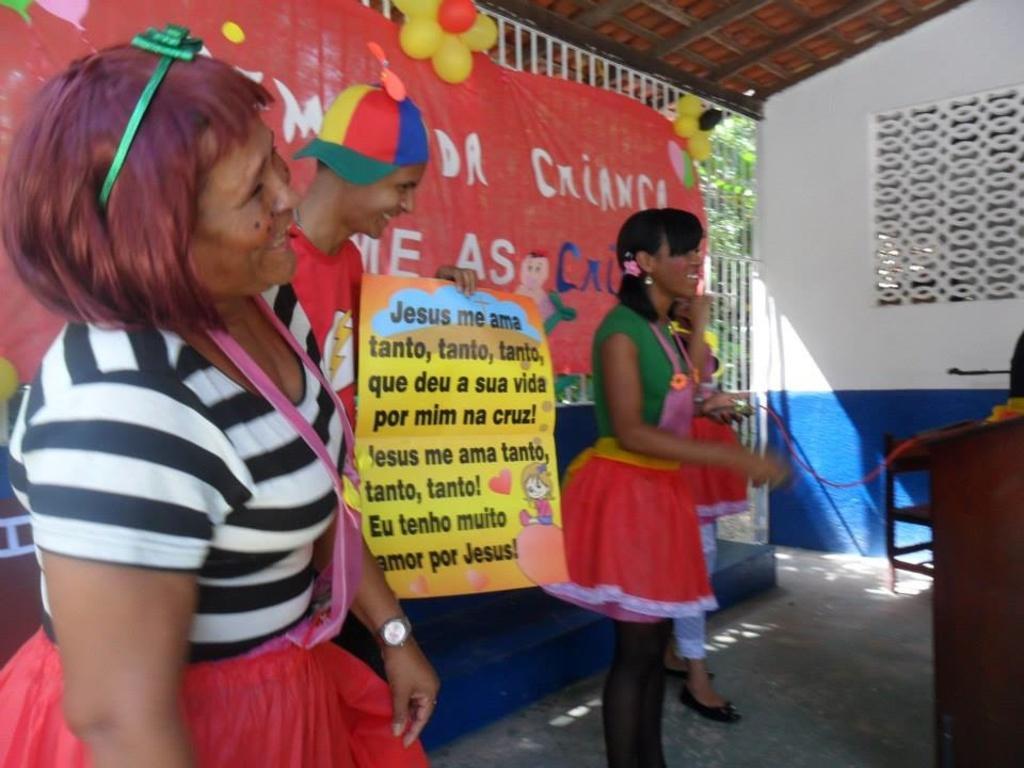Describe this image in one or two sentences. In this image I can see the group of people with different color dresses. In the back I can see the banner and the trees. To the right I can see the podium and mic on it. I can also see the balloons in the back. 